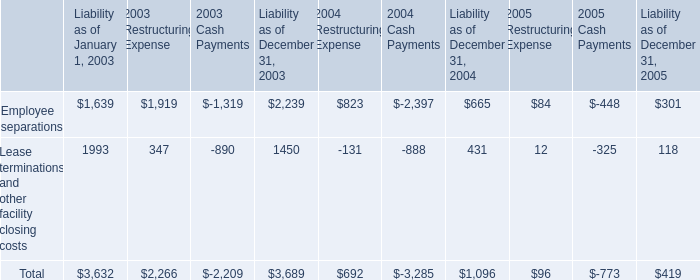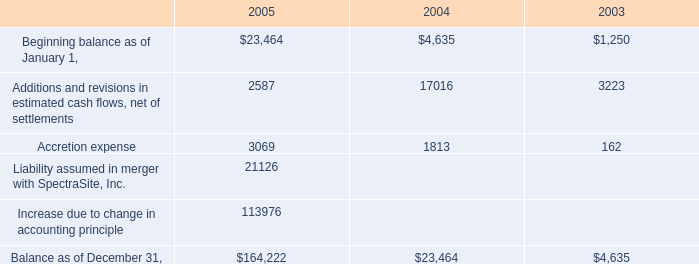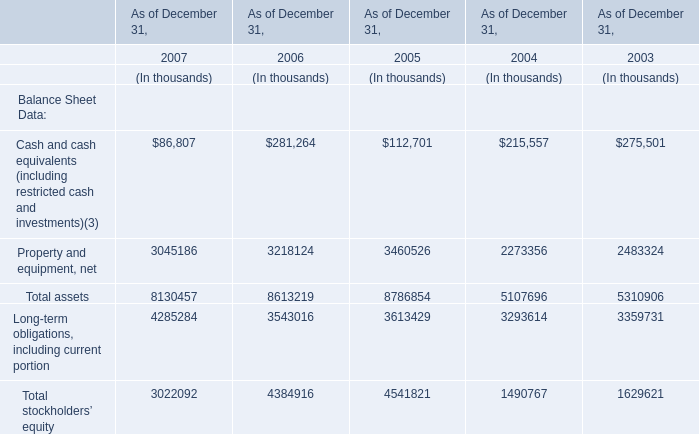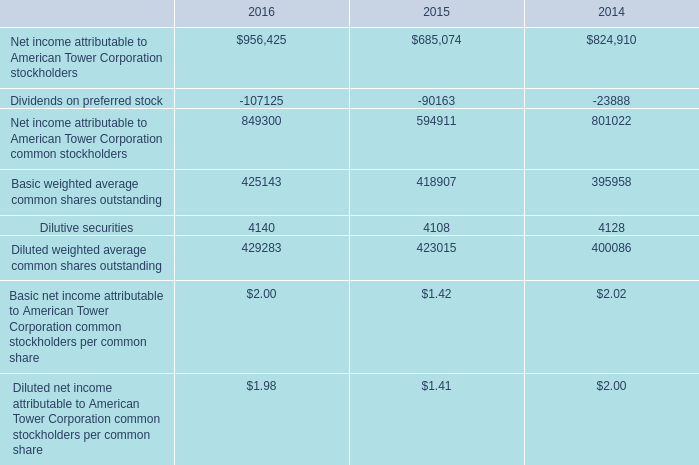What is the Total assets to the total in 2007? (in %) 
Computations: (8130457 / ((((8130457 + 8613219) + 8786854) + 5107696) + 5310906))
Answer: 0.22617. 